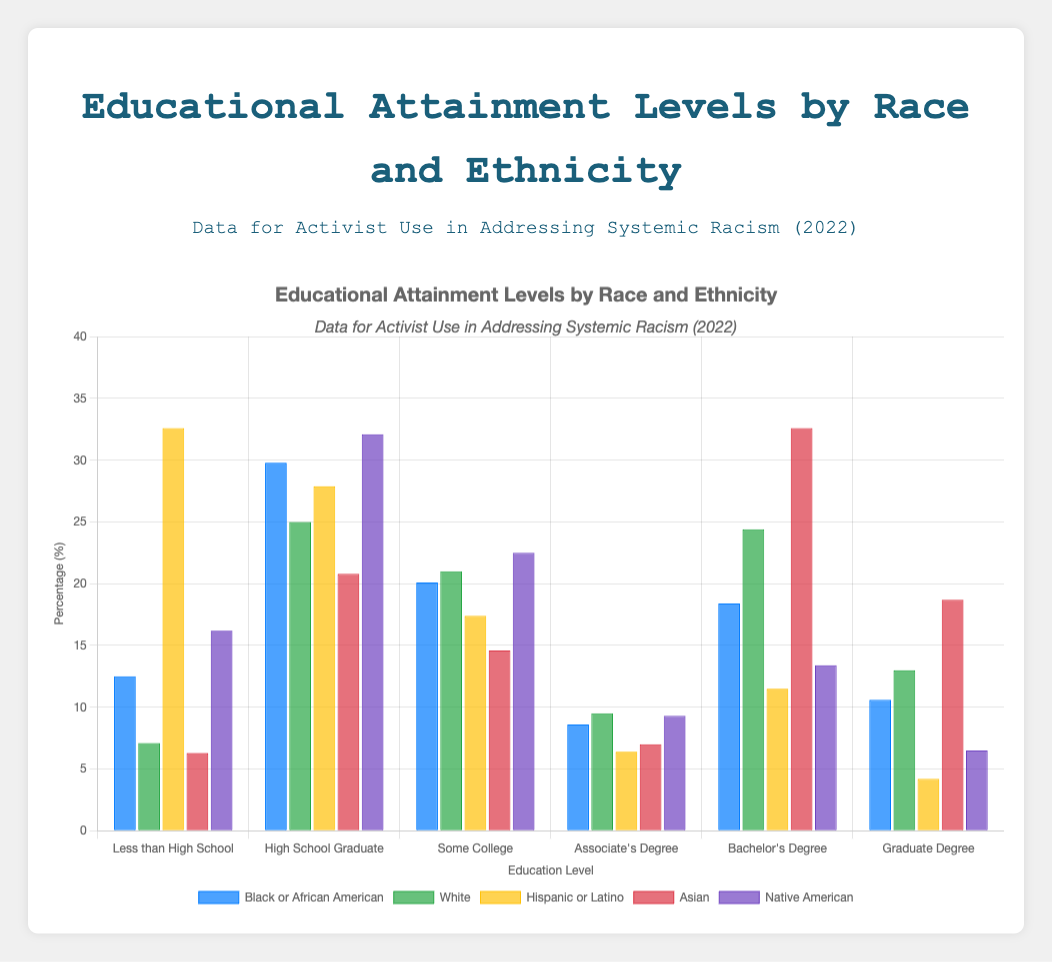What is the percentage of Black or African American individuals with a Bachelor's Degree? According to the bar chart, we look for the blue bar representing "Black or African American" in the "Bachelor's Degree" category. The height indicates 18.4%.
Answer: 18.4% Which group has the highest percentage of individuals with less than a High School education? By visually inspecting the heights of the bars in the "Less than High School" category, the tallest bar belongs to the Hispanic or Latino group with 32.6%.
Answer: Hispanic or Latino How does the percentage of White individuals with a Graduate Degree compare to that of Asian individuals? Look at the "Graduate Degree" category and compare the heights of the blue bars for "White" and "Asian." White individuals have 13.0%, while Asian individuals have 18.7%. 18.7% is higher than 13.0%.
Answer: Higher What is the approximate difference in percentages between Native American and Hispanic or Latino individuals who are High School Graduates? In the "High School Graduate" category, Native American individuals are at 32.1%, and Hispanic or Latino individuals are at 27.9%. The difference is 32.1% - 27.9% = 4.2%.
Answer: 4.2% Which racial/ethnic group has the smallest percentage of individuals with an Associate's Degree? Comparing the heights of the bars in the "Associate's Degree" category, the shortest bar represents Hispanic or Latino individuals with 6.4%.
Answer: Hispanic or Latino What is the sum of the percentages of Asian individuals with a Bachelor's Degree and Graduate Degree? Look at the "Bachelor's Degree" and "Graduate Degree" categories for Asian individuals. Sum 32.6% (Bachelor's) and 18.7% (Graduate): 32.6% + 18.7% = 51.3%.
Answer: 51.3% Among all groups, which has the highest educational attainment in the Bachelor's Degree category? By surveying the longest bar in the "Bachelor's Degree" category, Asian individuals have the highest percentage, reaching up to 32.6%.
Answer: Asian Compare the percentage of Black or African American High School Graduates to that of Native American High School Graduates. Which group has a higher percentage? Inspect the "High School Graduate" category: Black or African American individuals are at 29.8%, while Native American individuals are at 32.1%. Native American individuals have a higher percentage.
Answer: Native American 